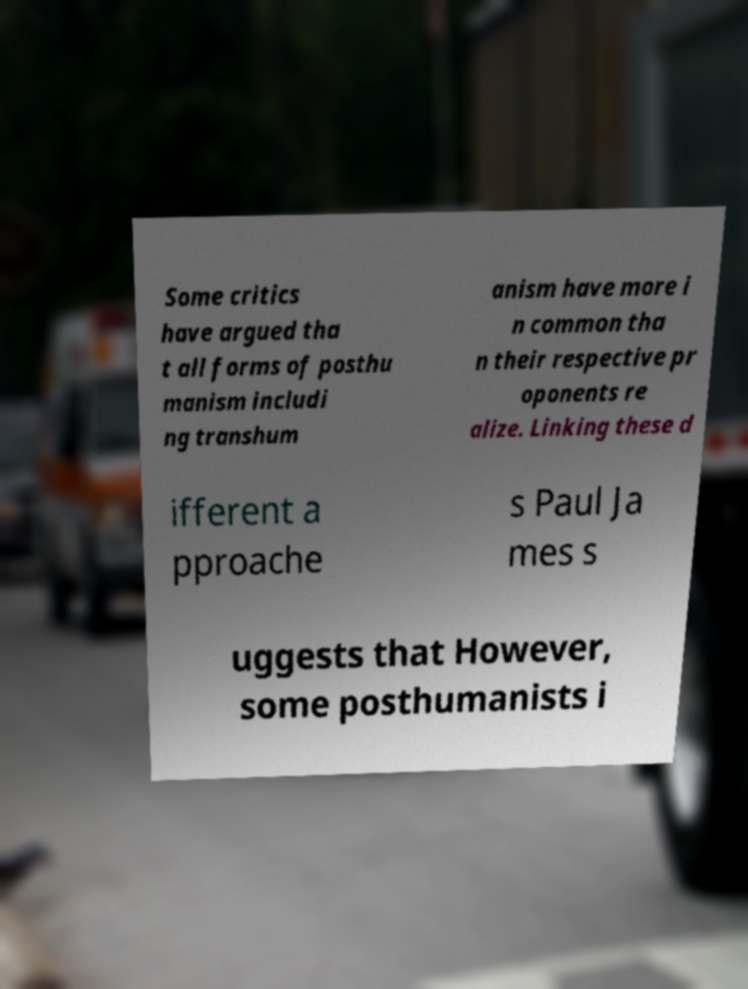Please read and relay the text visible in this image. What does it say? Some critics have argued tha t all forms of posthu manism includi ng transhum anism have more i n common tha n their respective pr oponents re alize. Linking these d ifferent a pproache s Paul Ja mes s uggests that However, some posthumanists i 